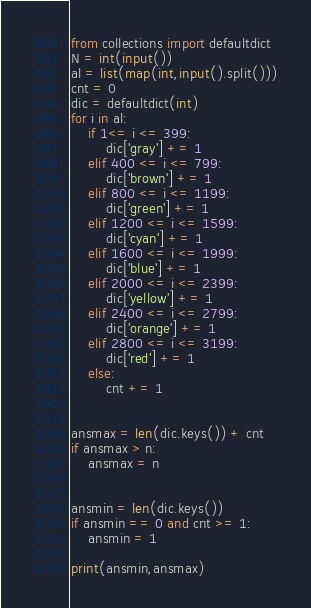Convert code to text. <code><loc_0><loc_0><loc_500><loc_500><_Python_>from collections import defaultdict
N = int(input())
al = list(map(int,input().split()))
cnt = 0
dic = defaultdict(int)
for i in al:
    if 1<= i <= 399:
        dic['gray'] += 1
    elif 400 <= i <= 799:
        dic['brown'] += 1
    elif 800 <= i <= 1199:
        dic['green'] += 1
    elif 1200 <= i <= 1599:
        dic['cyan'] += 1
    elif 1600 <= i <= 1999:
        dic['blue'] += 1
    elif 2000 <= i <= 2399:
        dic['yellow'] += 1
    elif 2400 <= i <= 2799:
        dic['orange'] += 1
    elif 2800 <= i <= 3199:
        dic['red'] += 1
    else:
        cnt += 1


ansmax = len(dic.keys()) + cnt
if ansmax > n:
    ansmax = n


ansmin = len(dic.keys())
if ansmin == 0 and cnt >= 1:
    ansmin = 1

print(ansmin,ansmax)</code> 